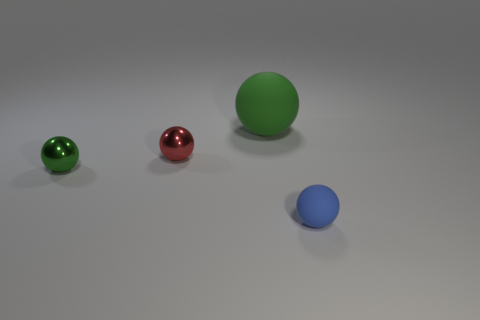There is a red metal thing that is the same shape as the big green rubber thing; what size is it?
Ensure brevity in your answer.  Small. What is the material of the small ball that is both right of the tiny green ball and behind the small rubber sphere?
Provide a succinct answer. Metal. Is the color of the metal sphere that is on the left side of the red sphere the same as the small rubber ball?
Your answer should be compact. No. There is a tiny matte object; is its color the same as the small shiny sphere behind the green metal sphere?
Make the answer very short. No. There is a small green metallic sphere; are there any small green shiny spheres behind it?
Keep it short and to the point. No. Is the large green ball made of the same material as the blue sphere?
Your answer should be very brief. Yes. What is the material of the green thing that is the same size as the blue matte ball?
Your response must be concise. Metal. What number of objects are rubber objects that are to the left of the tiny blue ball or tiny red balls?
Ensure brevity in your answer.  2. Are there the same number of tiny blue things behind the big rubber object and small blue things?
Your response must be concise. No. Do the small rubber sphere and the big sphere have the same color?
Give a very brief answer. No. 